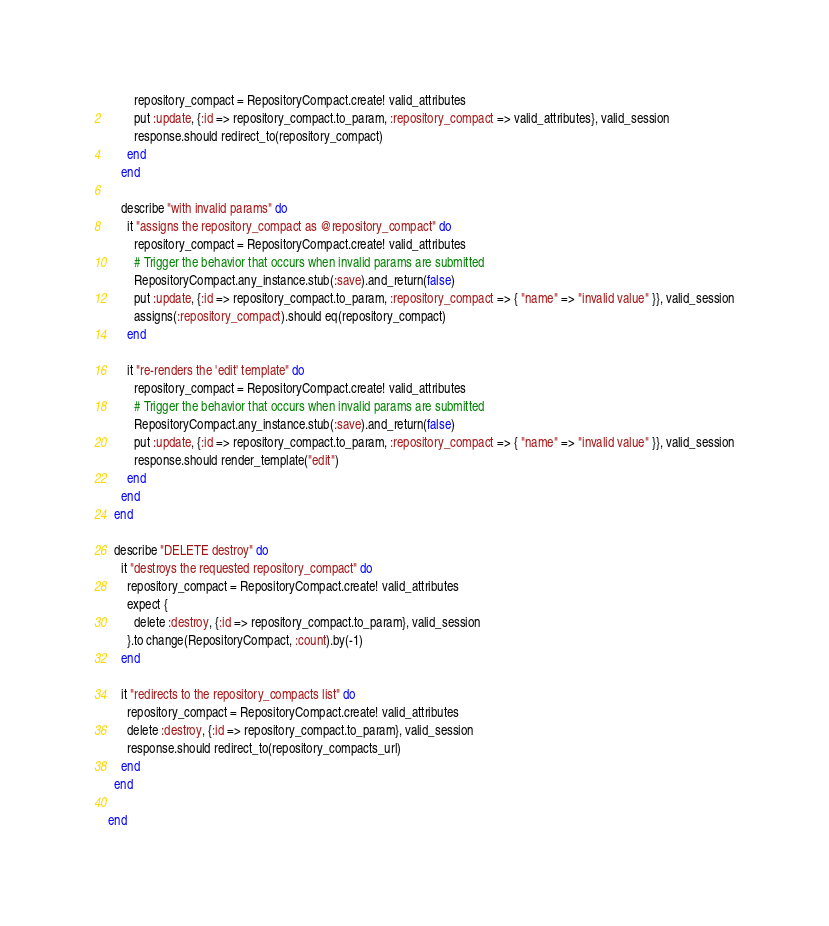<code> <loc_0><loc_0><loc_500><loc_500><_Ruby_>        repository_compact = RepositoryCompact.create! valid_attributes
        put :update, {:id => repository_compact.to_param, :repository_compact => valid_attributes}, valid_session
        response.should redirect_to(repository_compact)
      end
    end

    describe "with invalid params" do
      it "assigns the repository_compact as @repository_compact" do
        repository_compact = RepositoryCompact.create! valid_attributes
        # Trigger the behavior that occurs when invalid params are submitted
        RepositoryCompact.any_instance.stub(:save).and_return(false)
        put :update, {:id => repository_compact.to_param, :repository_compact => { "name" => "invalid value" }}, valid_session
        assigns(:repository_compact).should eq(repository_compact)
      end

      it "re-renders the 'edit' template" do
        repository_compact = RepositoryCompact.create! valid_attributes
        # Trigger the behavior that occurs when invalid params are submitted
        RepositoryCompact.any_instance.stub(:save).and_return(false)
        put :update, {:id => repository_compact.to_param, :repository_compact => { "name" => "invalid value" }}, valid_session
        response.should render_template("edit")
      end
    end
  end

  describe "DELETE destroy" do
    it "destroys the requested repository_compact" do
      repository_compact = RepositoryCompact.create! valid_attributes
      expect {
        delete :destroy, {:id => repository_compact.to_param}, valid_session
      }.to change(RepositoryCompact, :count).by(-1)
    end

    it "redirects to the repository_compacts list" do
      repository_compact = RepositoryCompact.create! valid_attributes
      delete :destroy, {:id => repository_compact.to_param}, valid_session
      response.should redirect_to(repository_compacts_url)
    end
  end

end
</code> 